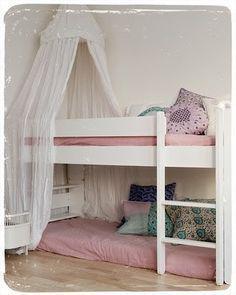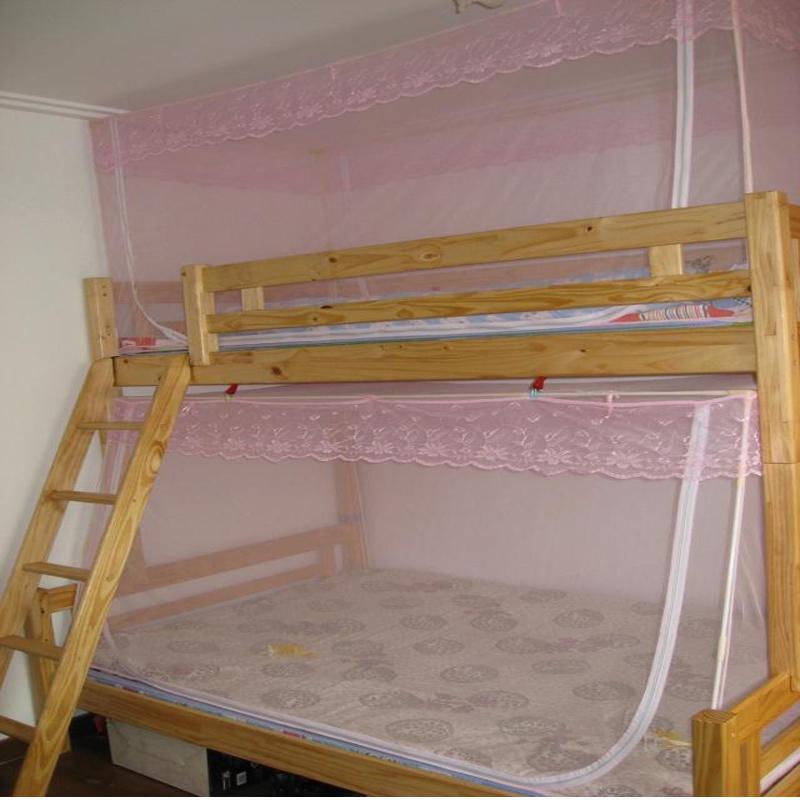The first image is the image on the left, the second image is the image on the right. Analyze the images presented: Is the assertion "An image shows a ceiling-suspended tent-shaped gauze canopy over bunk beds." valid? Answer yes or no. Yes. 